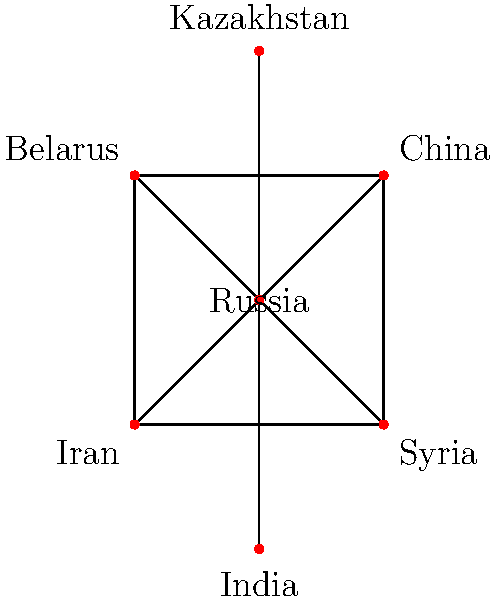In the given network diagram representing diplomatic relations between Russia and other countries, what is the degree centrality of Russia? How does this reflect Russia's position in this diplomatic network? To answer this question, we need to follow these steps:

1. Understand degree centrality:
   Degree centrality is a measure of the number of direct connections a node has in a network.

2. Count Russia's connections:
   From the diagram, we can see that Russia (the central node) is directly connected to:
   - China
   - Belarus
   - Iran
   - Syria
   - Kazakhstan
   - India

3. Calculate degree centrality:
   The degree centrality of Russia is simply the number of its direct connections.
   Degree centrality of Russia = 6

4. Interpret the result:
   This high degree centrality indicates that Russia has the most direct diplomatic connections in this network. It suggests that Russia plays a central role in this diplomatic network, potentially having significant influence or serving as a key mediator in international relations among these countries.

5. Compare to other nodes:
   We can observe that no other country in this network has as many connections as Russia, further emphasizing Russia's central position.

6. Consider network structure:
   The star-like structure with Russia at the center suggests that Russia might be a hub for diplomatic communications or negotiations among these nations.
Answer: 6; central diplomatic hub 